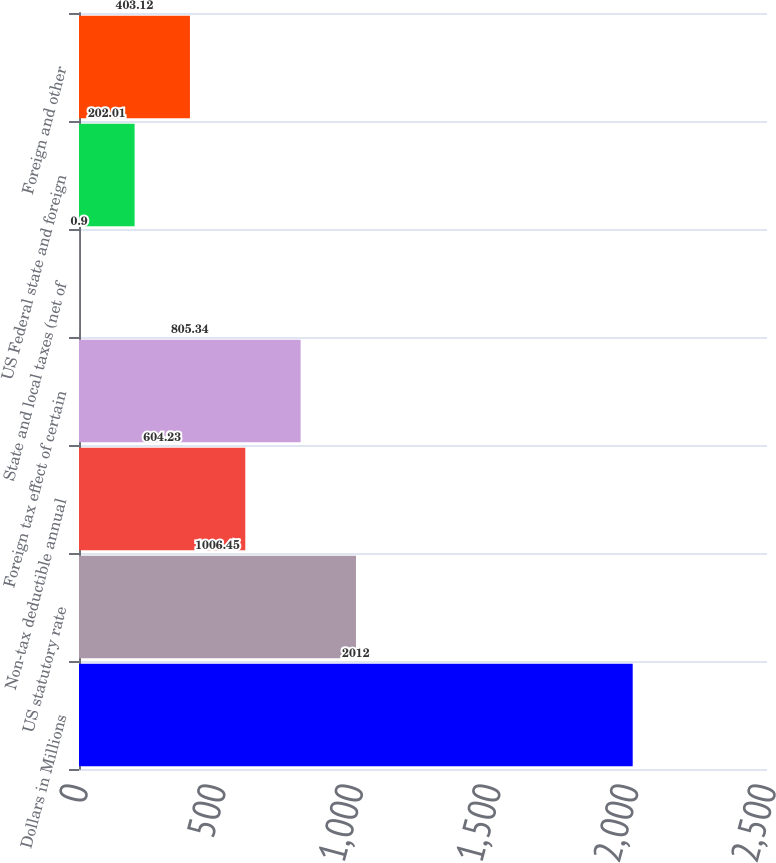Convert chart. <chart><loc_0><loc_0><loc_500><loc_500><bar_chart><fcel>Dollars in Millions<fcel>US statutory rate<fcel>Non-tax deductible annual<fcel>Foreign tax effect of certain<fcel>State and local taxes (net of<fcel>US Federal state and foreign<fcel>Foreign and other<nl><fcel>2012<fcel>1006.45<fcel>604.23<fcel>805.34<fcel>0.9<fcel>202.01<fcel>403.12<nl></chart> 